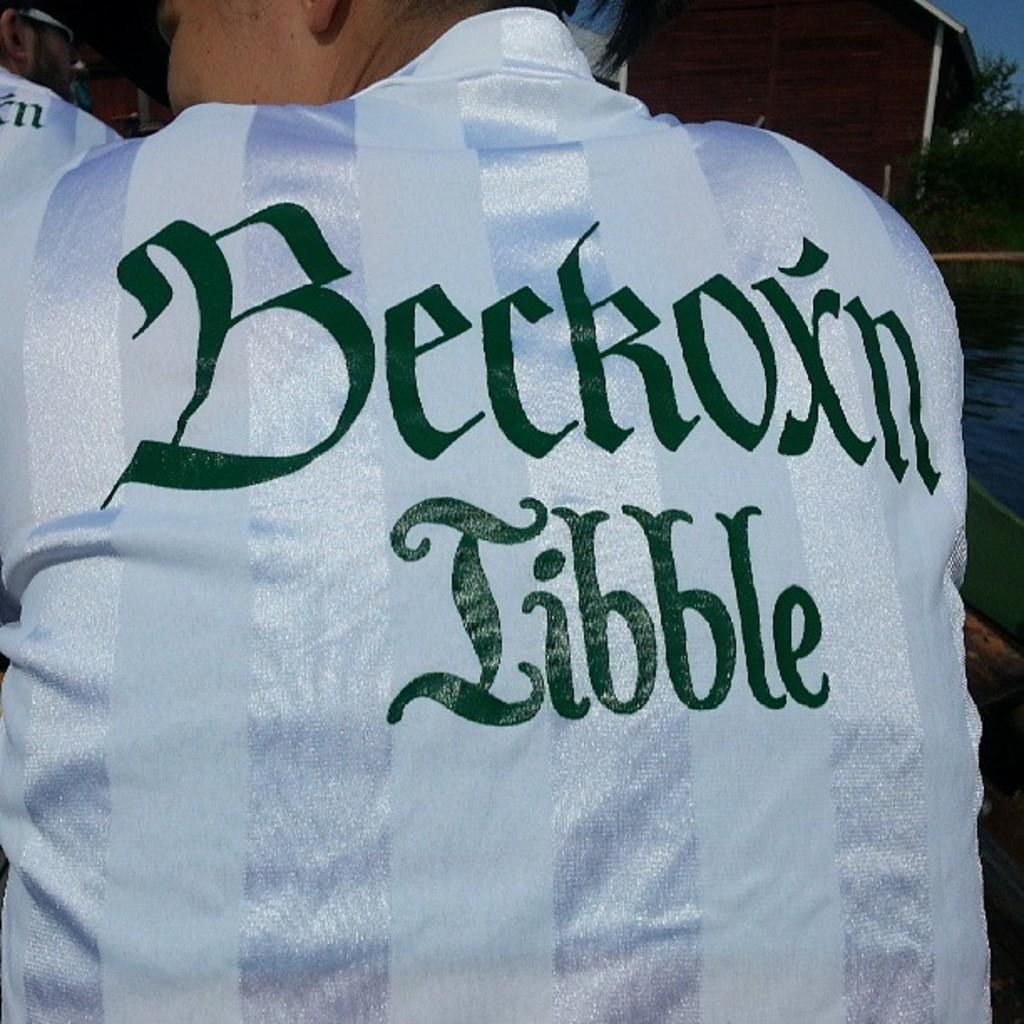<image>
Relay a brief, clear account of the picture shown. the back of man wearing white stripped beckoxn tibble shirt 